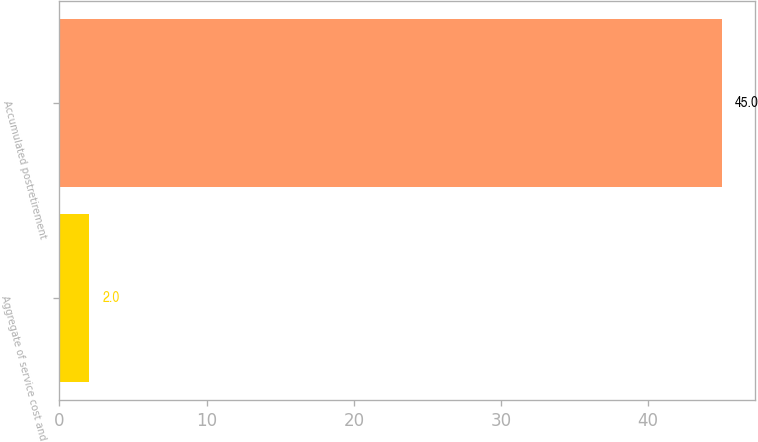<chart> <loc_0><loc_0><loc_500><loc_500><bar_chart><fcel>Aggregate of service cost and<fcel>Accumulated postretirement<nl><fcel>2<fcel>45<nl></chart> 